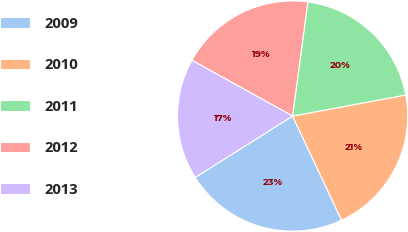<chart> <loc_0><loc_0><loc_500><loc_500><pie_chart><fcel>2009<fcel>2010<fcel>2011<fcel>2012<fcel>2013<nl><fcel>23.04%<fcel>20.93%<fcel>19.96%<fcel>19.06%<fcel>17.01%<nl></chart> 